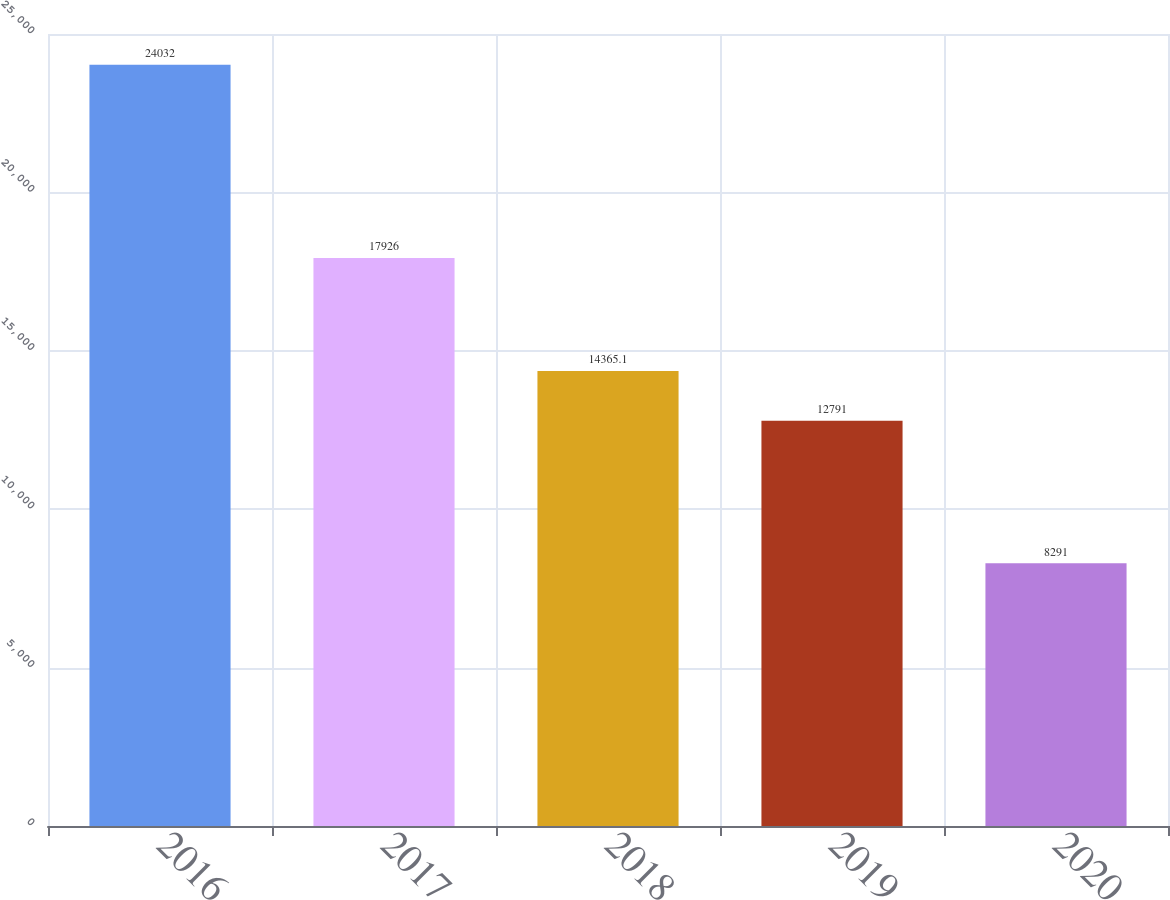Convert chart. <chart><loc_0><loc_0><loc_500><loc_500><bar_chart><fcel>2016<fcel>2017<fcel>2018<fcel>2019<fcel>2020<nl><fcel>24032<fcel>17926<fcel>14365.1<fcel>12791<fcel>8291<nl></chart> 